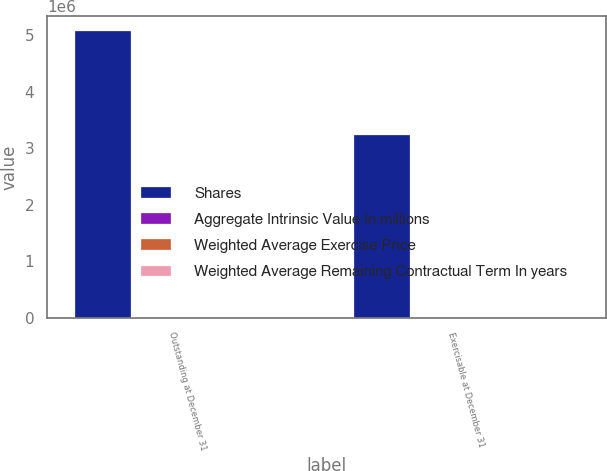<chart> <loc_0><loc_0><loc_500><loc_500><stacked_bar_chart><ecel><fcel>Outstanding at December 31<fcel>Exercisable at December 31<nl><fcel>Shares<fcel>5.0794e+06<fcel>3.23738e+06<nl><fcel>Aggregate Intrinsic Value In millions<fcel>24.22<fcel>23.46<nl><fcel>Weighted Average Exercise Price<fcel>4<fcel>3<nl><fcel>Weighted Average Remaining Contractual Term In years<fcel>8<fcel>8<nl></chart> 